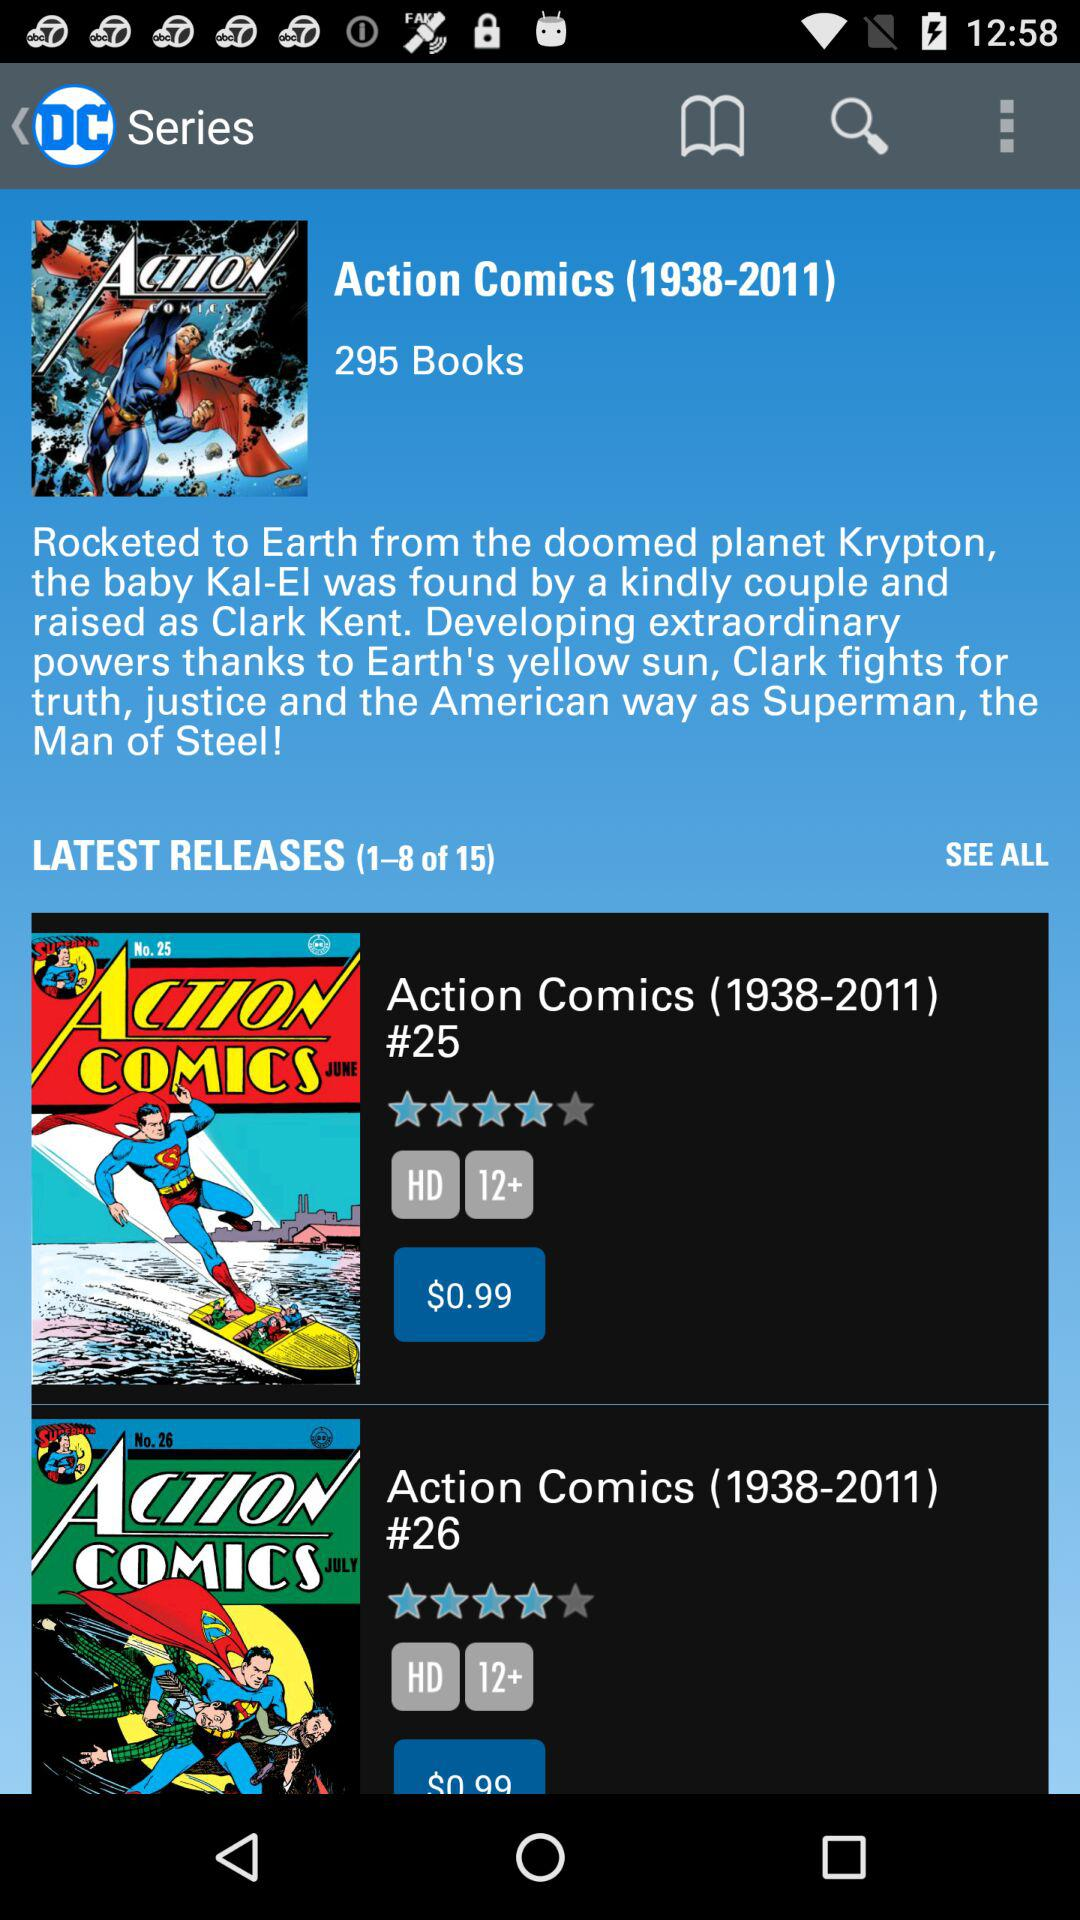What is the price of "Action Comics (1938-2011) #25"? The price of "Action Comics (1938-2011) #25" is $0.99. 